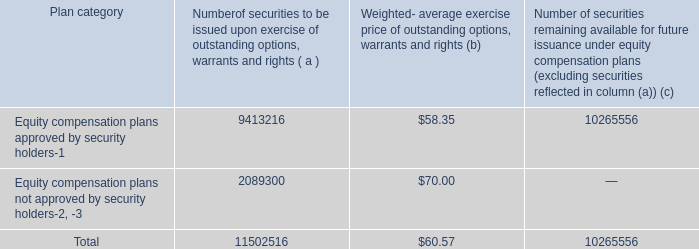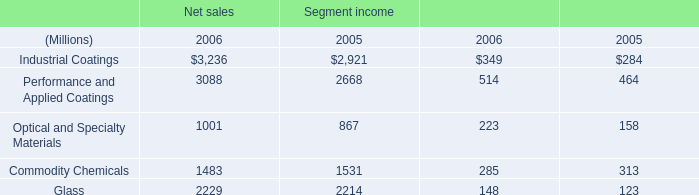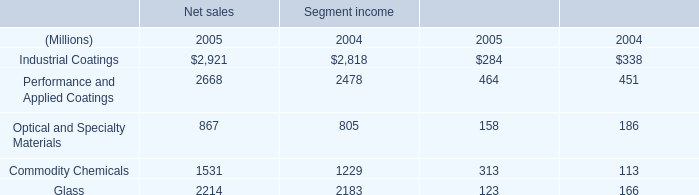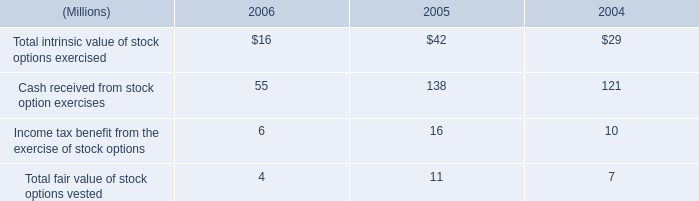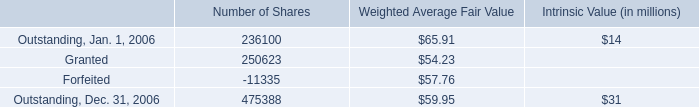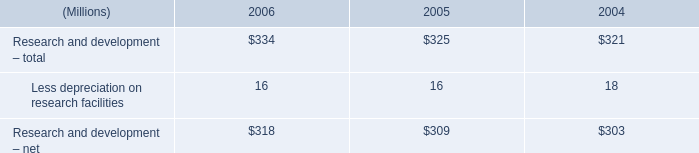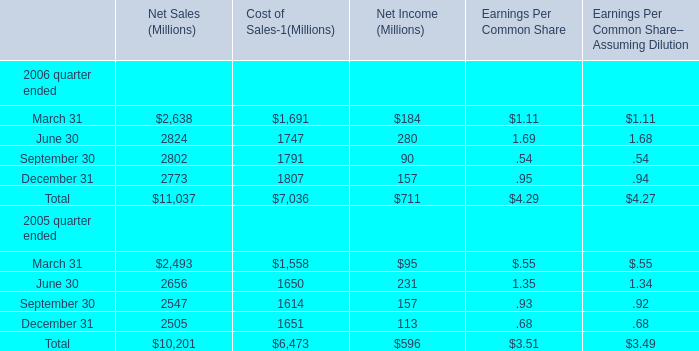What's the sum of Forfeited of Number of Shares, and Equity compensation plans approved by security holders of [EMPTY].1 ? 
Computations: (11335.0 + 9413216.0)
Answer: 9424551.0. 